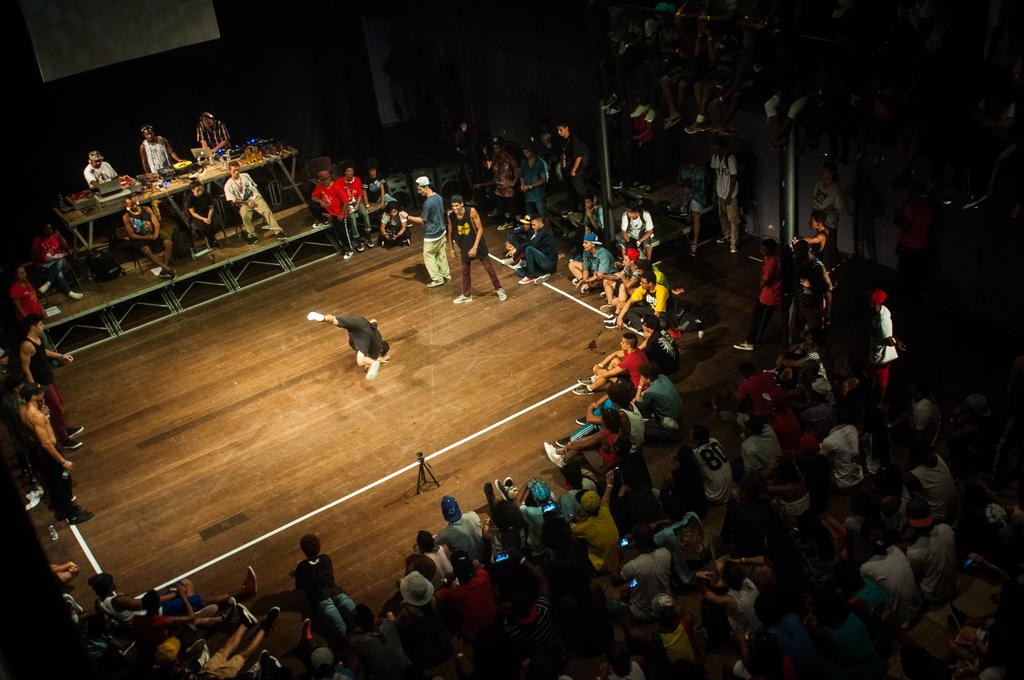How many groups of people can be seen in the image? There are two groups of people in the image, one standing and one sitting. What are the people doing in the image? The people are either standing or sitting, but their specific activities are not mentioned in the facts. What can be found on the tables in the image? There are objects on the tables in the image, but their specific nature is not mentioned in the facts. What is the purpose of the screen in the image? The purpose of the screen in the image is not mentioned in the facts. What type of feast is being prepared on the floor in the image? There is no mention of a feast or the floor in the image, so this question cannot be answered definitively. 